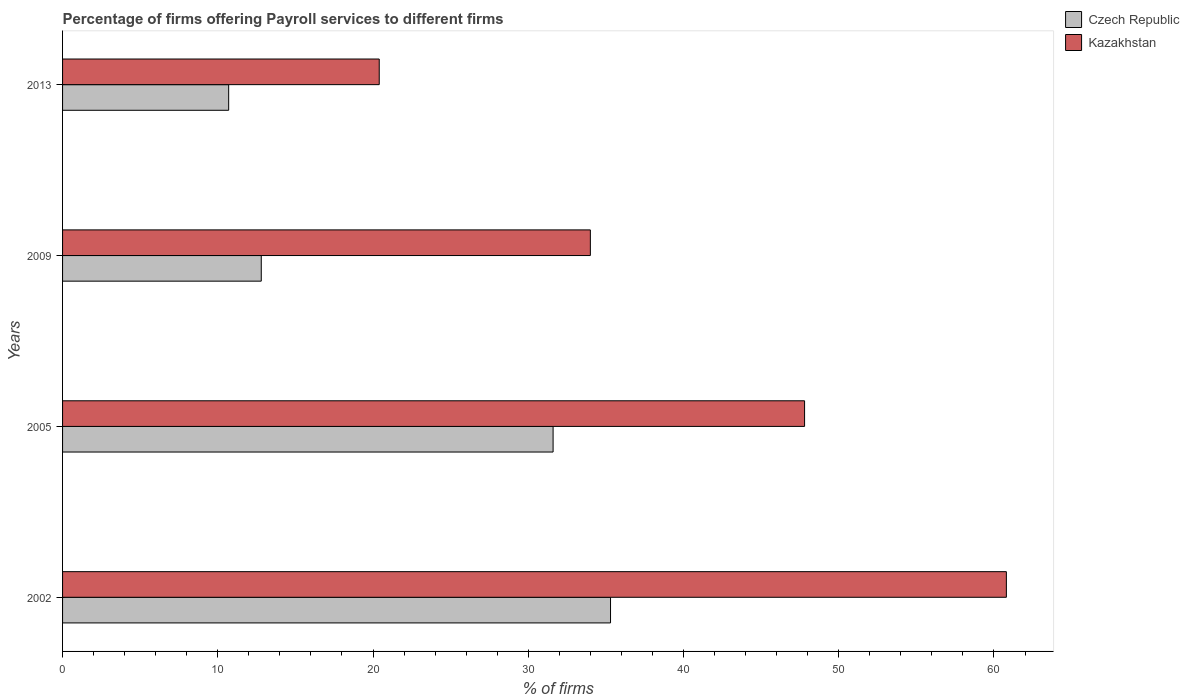How many different coloured bars are there?
Provide a short and direct response. 2. How many groups of bars are there?
Your answer should be very brief. 4. Are the number of bars per tick equal to the number of legend labels?
Provide a succinct answer. Yes. Are the number of bars on each tick of the Y-axis equal?
Your answer should be compact. Yes. How many bars are there on the 4th tick from the bottom?
Provide a short and direct response. 2. What is the percentage of firms offering payroll services in Kazakhstan in 2005?
Provide a succinct answer. 47.8. Across all years, what is the maximum percentage of firms offering payroll services in Czech Republic?
Give a very brief answer. 35.3. What is the total percentage of firms offering payroll services in Kazakhstan in the graph?
Your answer should be compact. 163. What is the difference between the percentage of firms offering payroll services in Kazakhstan in 2002 and that in 2013?
Offer a terse response. 40.4. What is the difference between the percentage of firms offering payroll services in Czech Republic in 2009 and the percentage of firms offering payroll services in Kazakhstan in 2002?
Keep it short and to the point. -48. What is the average percentage of firms offering payroll services in Czech Republic per year?
Provide a short and direct response. 22.6. In how many years, is the percentage of firms offering payroll services in Czech Republic greater than 48 %?
Your response must be concise. 0. What is the ratio of the percentage of firms offering payroll services in Czech Republic in 2002 to that in 2013?
Make the answer very short. 3.3. Is the difference between the percentage of firms offering payroll services in Czech Republic in 2005 and 2009 greater than the difference between the percentage of firms offering payroll services in Kazakhstan in 2005 and 2009?
Keep it short and to the point. Yes. What is the difference between the highest and the second highest percentage of firms offering payroll services in Kazakhstan?
Offer a very short reply. 13. What is the difference between the highest and the lowest percentage of firms offering payroll services in Kazakhstan?
Offer a terse response. 40.4. In how many years, is the percentage of firms offering payroll services in Kazakhstan greater than the average percentage of firms offering payroll services in Kazakhstan taken over all years?
Ensure brevity in your answer.  2. Is the sum of the percentage of firms offering payroll services in Kazakhstan in 2002 and 2005 greater than the maximum percentage of firms offering payroll services in Czech Republic across all years?
Make the answer very short. Yes. What does the 1st bar from the top in 2005 represents?
Make the answer very short. Kazakhstan. What does the 2nd bar from the bottom in 2002 represents?
Provide a short and direct response. Kazakhstan. How many bars are there?
Offer a very short reply. 8. What is the difference between two consecutive major ticks on the X-axis?
Your answer should be very brief. 10. Are the values on the major ticks of X-axis written in scientific E-notation?
Provide a succinct answer. No. Where does the legend appear in the graph?
Give a very brief answer. Top right. How many legend labels are there?
Give a very brief answer. 2. What is the title of the graph?
Ensure brevity in your answer.  Percentage of firms offering Payroll services to different firms. Does "Central African Republic" appear as one of the legend labels in the graph?
Make the answer very short. No. What is the label or title of the X-axis?
Your answer should be compact. % of firms. What is the label or title of the Y-axis?
Your response must be concise. Years. What is the % of firms of Czech Republic in 2002?
Keep it short and to the point. 35.3. What is the % of firms of Kazakhstan in 2002?
Provide a short and direct response. 60.8. What is the % of firms in Czech Republic in 2005?
Keep it short and to the point. 31.6. What is the % of firms of Kazakhstan in 2005?
Offer a terse response. 47.8. What is the % of firms of Kazakhstan in 2009?
Give a very brief answer. 34. What is the % of firms in Kazakhstan in 2013?
Ensure brevity in your answer.  20.4. Across all years, what is the maximum % of firms in Czech Republic?
Ensure brevity in your answer.  35.3. Across all years, what is the maximum % of firms of Kazakhstan?
Give a very brief answer. 60.8. Across all years, what is the minimum % of firms in Kazakhstan?
Give a very brief answer. 20.4. What is the total % of firms in Czech Republic in the graph?
Make the answer very short. 90.4. What is the total % of firms in Kazakhstan in the graph?
Keep it short and to the point. 163. What is the difference between the % of firms of Czech Republic in 2002 and that in 2009?
Your answer should be compact. 22.5. What is the difference between the % of firms in Kazakhstan in 2002 and that in 2009?
Ensure brevity in your answer.  26.8. What is the difference between the % of firms of Czech Republic in 2002 and that in 2013?
Provide a succinct answer. 24.6. What is the difference between the % of firms in Kazakhstan in 2002 and that in 2013?
Your response must be concise. 40.4. What is the difference between the % of firms of Czech Republic in 2005 and that in 2009?
Ensure brevity in your answer.  18.8. What is the difference between the % of firms in Kazakhstan in 2005 and that in 2009?
Provide a short and direct response. 13.8. What is the difference between the % of firms in Czech Republic in 2005 and that in 2013?
Keep it short and to the point. 20.9. What is the difference between the % of firms in Kazakhstan in 2005 and that in 2013?
Provide a short and direct response. 27.4. What is the difference between the % of firms in Czech Republic in 2002 and the % of firms in Kazakhstan in 2005?
Your answer should be compact. -12.5. What is the average % of firms in Czech Republic per year?
Keep it short and to the point. 22.6. What is the average % of firms in Kazakhstan per year?
Ensure brevity in your answer.  40.75. In the year 2002, what is the difference between the % of firms of Czech Republic and % of firms of Kazakhstan?
Ensure brevity in your answer.  -25.5. In the year 2005, what is the difference between the % of firms in Czech Republic and % of firms in Kazakhstan?
Give a very brief answer. -16.2. In the year 2009, what is the difference between the % of firms in Czech Republic and % of firms in Kazakhstan?
Ensure brevity in your answer.  -21.2. What is the ratio of the % of firms in Czech Republic in 2002 to that in 2005?
Provide a short and direct response. 1.12. What is the ratio of the % of firms in Kazakhstan in 2002 to that in 2005?
Provide a short and direct response. 1.27. What is the ratio of the % of firms in Czech Republic in 2002 to that in 2009?
Provide a succinct answer. 2.76. What is the ratio of the % of firms in Kazakhstan in 2002 to that in 2009?
Provide a succinct answer. 1.79. What is the ratio of the % of firms in Czech Republic in 2002 to that in 2013?
Keep it short and to the point. 3.3. What is the ratio of the % of firms of Kazakhstan in 2002 to that in 2013?
Offer a very short reply. 2.98. What is the ratio of the % of firms of Czech Republic in 2005 to that in 2009?
Your response must be concise. 2.47. What is the ratio of the % of firms in Kazakhstan in 2005 to that in 2009?
Make the answer very short. 1.41. What is the ratio of the % of firms of Czech Republic in 2005 to that in 2013?
Provide a succinct answer. 2.95. What is the ratio of the % of firms in Kazakhstan in 2005 to that in 2013?
Your answer should be very brief. 2.34. What is the ratio of the % of firms in Czech Republic in 2009 to that in 2013?
Your response must be concise. 1.2. What is the difference between the highest and the second highest % of firms in Czech Republic?
Your answer should be very brief. 3.7. What is the difference between the highest and the second highest % of firms of Kazakhstan?
Give a very brief answer. 13. What is the difference between the highest and the lowest % of firms in Czech Republic?
Give a very brief answer. 24.6. What is the difference between the highest and the lowest % of firms in Kazakhstan?
Your answer should be very brief. 40.4. 